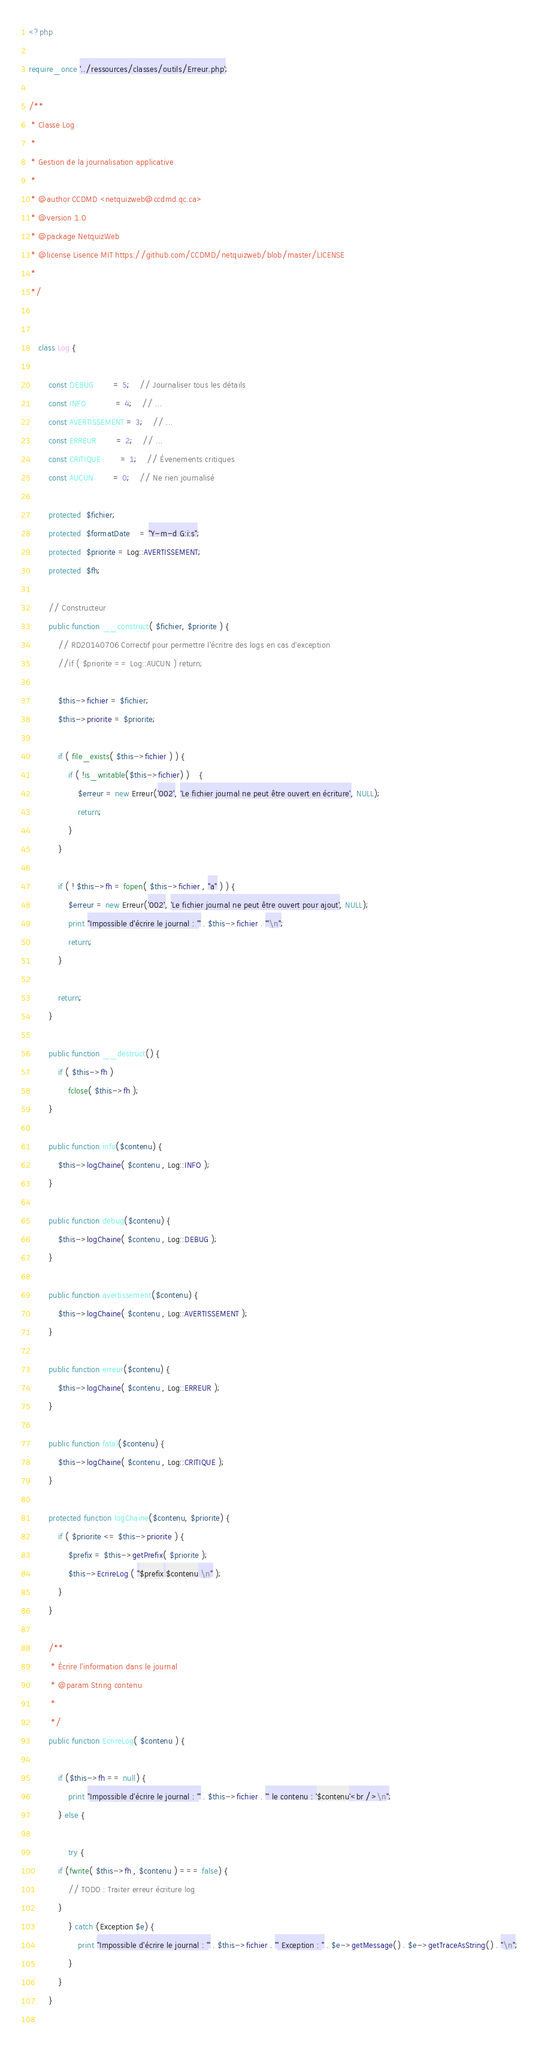<code> <loc_0><loc_0><loc_500><loc_500><_PHP_><?php

require_once '../ressources/classes/outils/Erreur.php';

/** 
 * Classe Log
 * 
 * Gestion de la journalisation applicative
 *
 * @author CCDMD <netquizweb@ccdmd.qc.ca> 
 * @version 1.0
 * @package NetquizWeb
 * @license Lisence MIT https://github.com/CCDMD/netquizweb/blob/master/LICENSE
 *
 */

	
	class Log {
		
		const DEBUG 		= 5;	// Journaliser tous les détails 
		const INFO 			= 4;	// ...
		const AVERTISSEMENT = 3;	// ...
		const ERREUR 		= 2;	// ...
		const CRITIQUE 		= 1;	// Évenements critiques
		const AUCUN 		= 0;	// Ne rien journalisé
		
		protected  $fichier;
		protected  $formatDate	= "Y-m-d G:i:s";
		protected  $priorite = Log::AVERTISSEMENT;
		protected  $fh;

		// Constructeur
		public function __construct( $fichier, $priorite ) {
			// RD20140706 Correctif pour permettre l'écritre des logs en cas d'exception
			//if ( $priorite == Log::AUCUN ) return;
			
			$this->fichier = $fichier;
			$this->priorite = $priorite;
			
			if ( file_exists( $this->fichier ) ) {
				if ( !is_writable($this->fichier) )	{
					$erreur = new Erreur('002', 'Le fichier journal ne peut être ouvert en écriture', NULL);
					return;
				}
			}
			
			if ( ! $this->fh = fopen( $this->fichier , "a" ) ) {
				$erreur = new Erreur('002', 'Le fichier journal ne peut être ouvert pour ajout', NULL);
				print "Impossible d'écrire le journal : '" . $this->fichier . "'\n";
				return;
			}
			
			return;
		}
		
		public function __destruct() {
			if ( $this->fh )
				fclose( $this->fh );
		}
		
		public function info($contenu) {
			$this->logChaine( $contenu , Log::INFO );
		}
		
		public function debug($contenu) {
			$this->logChaine( $contenu , Log::DEBUG );
		}
		
		public function avertissement($contenu) {
			$this->logChaine( $contenu , Log::AVERTISSEMENT );	
		}
		
		public function erreur($contenu) {
			$this->logChaine( $contenu , Log::ERREUR );		
		}

		public function fatal($contenu) {
			$this->logChaine( $contenu , Log::CRITIQUE );
		}
		
		protected function logChaine($contenu, $priorite) {
			if ( $priorite <= $this->priorite ) {
				$prefix = $this->getPrefix( $priorite );
				$this->EcrireLog ( "$prefix $contenu \n" );
			}
		}
		
		/**
		 * Écrire l'information dans le journal
		 * @param String contenu
		 * 
		 */
		public function EcrireLog( $contenu ) {
			
			if ($this->fh == null) {
				print "Impossible d'écrire le journal : '" . $this->fichier . "' le contenu : '$contenu'<br />\n";
			} else {
			
				try {
		    if (fwrite( $this->fh , $contenu ) === false) {
		        // TODO : Traiter erreur écriture log
		    }
				} catch (Exception $e) {
					print "Impossible d'écrire le journal : '" . $this->fichier . "' Exception : " . $e->getMessage() . $e->getTraceAsString() . "\n";
				}	
			}
		}
		</code> 